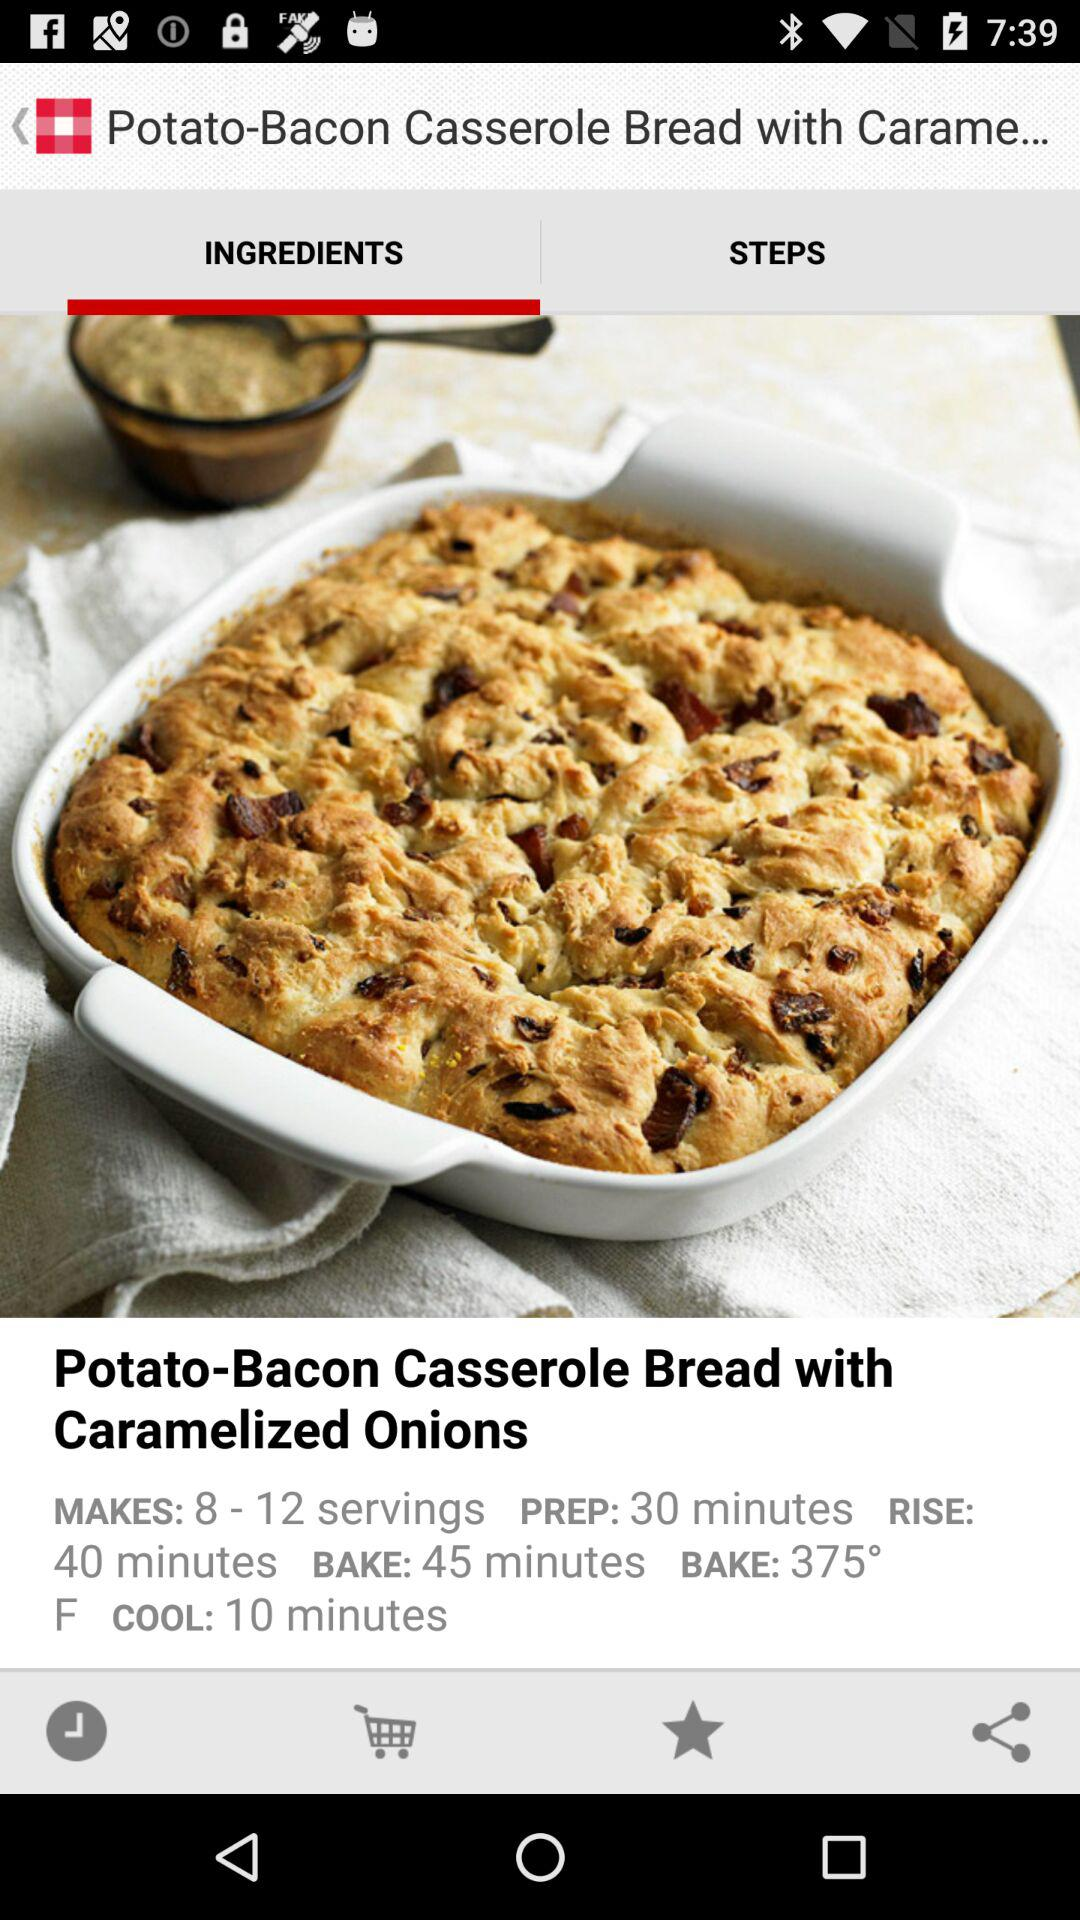How much time is needed to cool this food? There are 10 minutes needed to cool this food. 